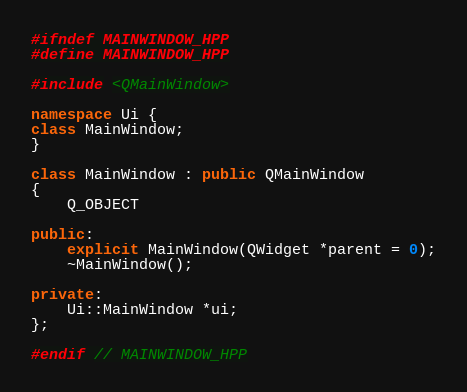Convert code to text. <code><loc_0><loc_0><loc_500><loc_500><_C++_>#ifndef MAINWINDOW_HPP
#define MAINWINDOW_HPP

#include <QMainWindow>

namespace Ui {
class MainWindow;
}

class MainWindow : public QMainWindow
{
    Q_OBJECT

public:
    explicit MainWindow(QWidget *parent = 0);
    ~MainWindow();

private:
    Ui::MainWindow *ui;
};

#endif // MAINWINDOW_HPP
</code> 